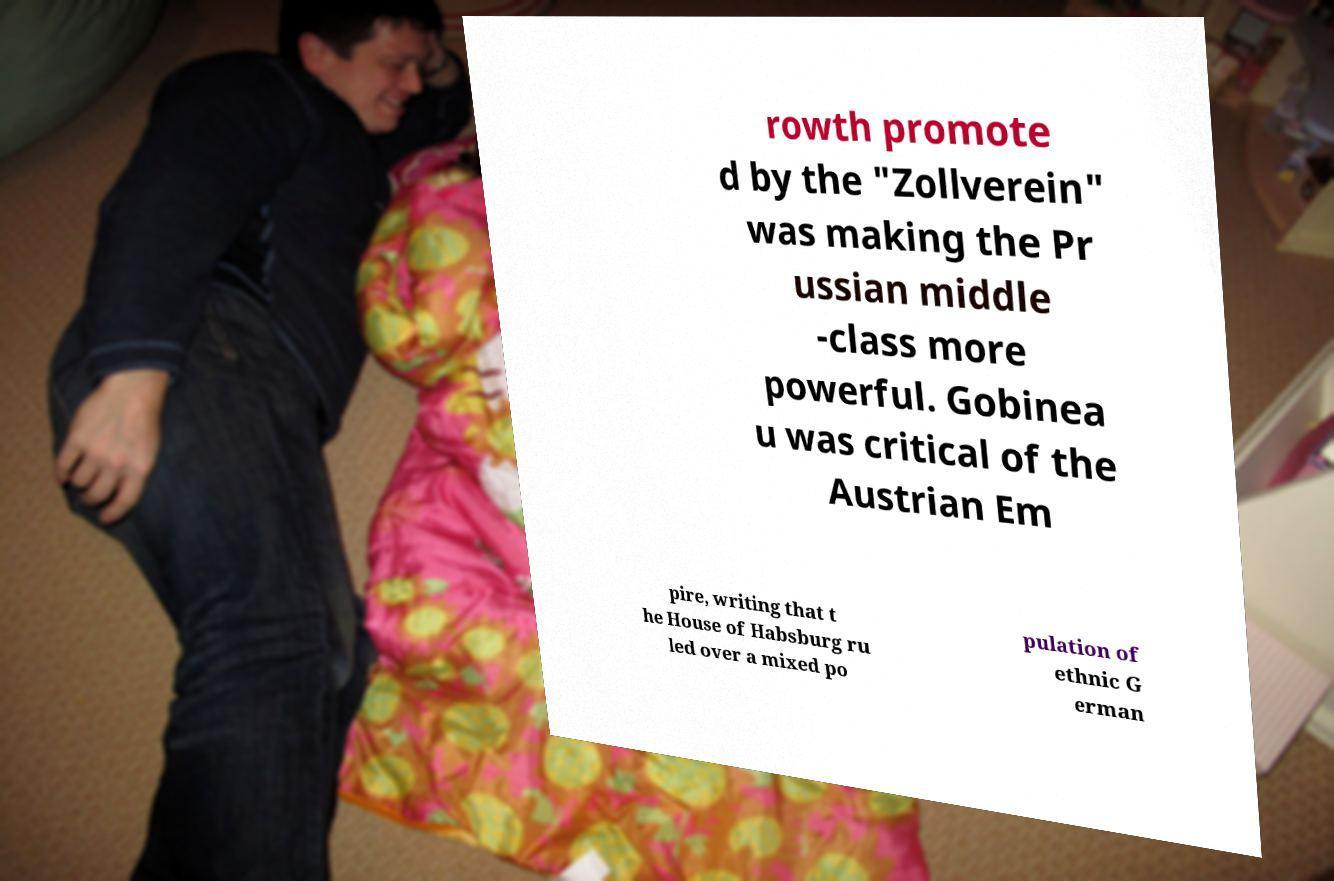I need the written content from this picture converted into text. Can you do that? rowth promote d by the "Zollverein" was making the Pr ussian middle -class more powerful. Gobinea u was critical of the Austrian Em pire, writing that t he House of Habsburg ru led over a mixed po pulation of ethnic G erman 